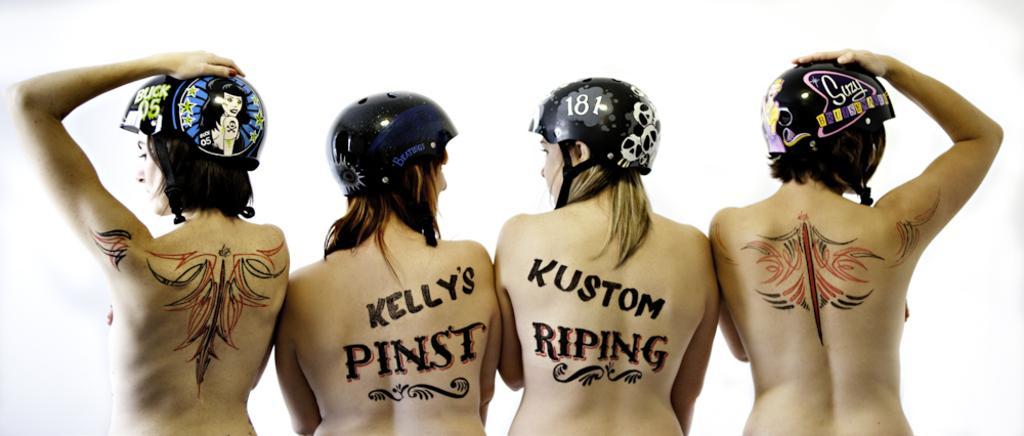Please provide a concise description of this image. In this picture we can see there are four women with the helmets. On the women back, it is written something and drawings. In front of the people it is in white color. 